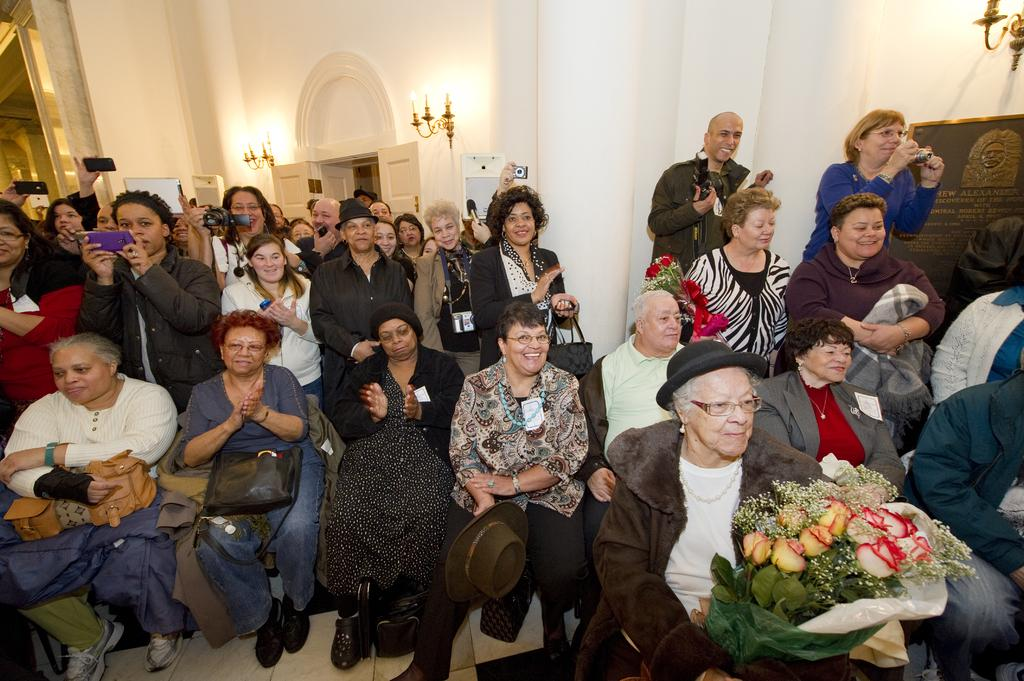Who is present in the image? There are people in the image, including men and women. Can you describe the setting of the image? There is a wall in the background of the image. What type of wrench is being used by the woman in the image? There is no wrench present in the image; the woman is not using any tools. 